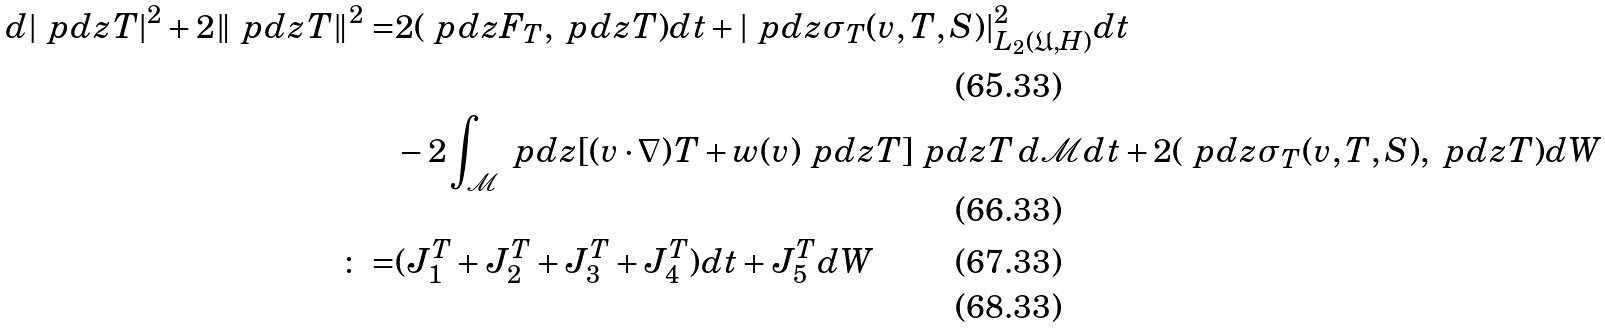<formula> <loc_0><loc_0><loc_500><loc_500>d | \ p d { z } T | ^ { 2 } + 2 \| \ p d { z } T \| ^ { 2 } = & 2 ( \ p d { z } F _ { T } , \ p d { z } T ) d t + | \ p d { z } \sigma _ { T } ( v , T , S ) | ^ { 2 } _ { L _ { 2 } ( \mathfrak { U } , H ) } d t \\ & - 2 \int _ { \mathcal { M } } \ p d { z } [ ( v \cdot \nabla ) T + w ( v ) \ p d { z } T ] \ p d { z } T \, d \mathcal { M } d t + 2 ( \ p d { z } \sigma _ { T } ( v , T , S ) , \ p d { z } T ) d W \\ \colon = & ( J _ { 1 } ^ { T } + J _ { 2 } ^ { T } + J _ { 3 } ^ { T } + J _ { 4 } ^ { T } ) d t + J _ { 5 } ^ { T } d W \\</formula> 